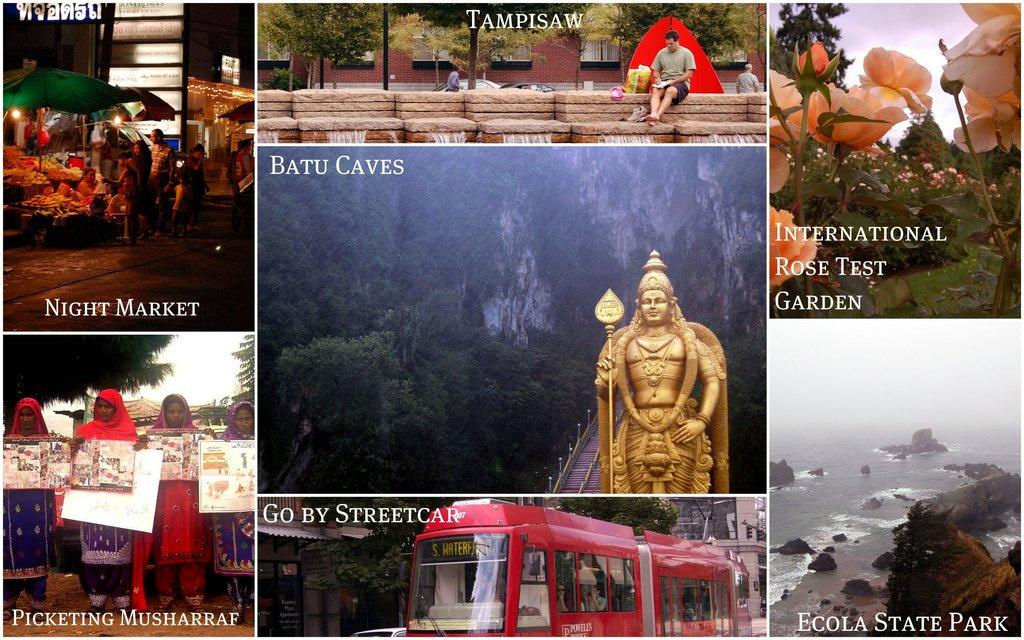Provide a one-sentence caption for the provided image. A multiple picture frame of various settings including Ecola state . 